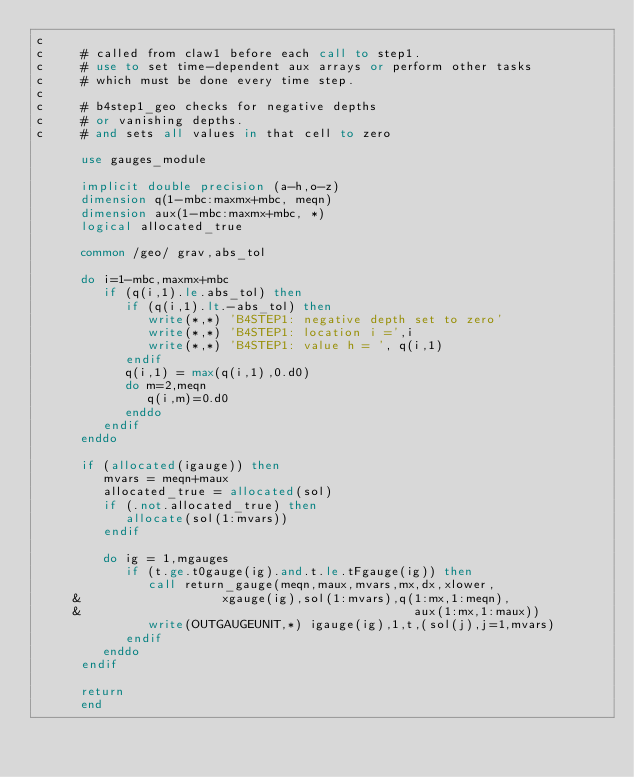<code> <loc_0><loc_0><loc_500><loc_500><_FORTRAN_>c
c     # called from claw1 before each call to step1.
c     # use to set time-dependent aux arrays or perform other tasks
c     # which must be done every time step.
c
c     # b4step1_geo checks for negative depths
c     # or vanishing depths.
c     # and sets all values in that cell to zero

      use gauges_module

      implicit double precision (a-h,o-z)
      dimension q(1-mbc:maxmx+mbc, meqn)
      dimension aux(1-mbc:maxmx+mbc, *)
      logical allocated_true

      common /geo/ grav,abs_tol

      do i=1-mbc,maxmx+mbc
         if (q(i,1).le.abs_tol) then
            if (q(i,1).lt.-abs_tol) then
               write(*,*) 'B4STEP1: negative depth set to zero'
               write(*,*) 'B4STEP1: location i =',i
               write(*,*) 'B4STEP1: value h = ', q(i,1)
            endif
            q(i,1) = max(q(i,1),0.d0)
            do m=2,meqn
               q(i,m)=0.d0
            enddo
         endif
      enddo

      if (allocated(igauge)) then
         mvars = meqn+maux
         allocated_true = allocated(sol)
         if (.not.allocated_true) then
            allocate(sol(1:mvars))
         endif

         do ig = 1,mgauges
            if (t.ge.t0gauge(ig).and.t.le.tFgauge(ig)) then
               call return_gauge(meqn,maux,mvars,mx,dx,xlower,
     &                   xgauge(ig),sol(1:mvars),q(1:mx,1:meqn),
     &                                             aux(1:mx,1:maux))
               write(OUTGAUGEUNIT,*) igauge(ig),1,t,(sol(j),j=1,mvars)
            endif
         enddo
      endif

      return
      end
</code> 